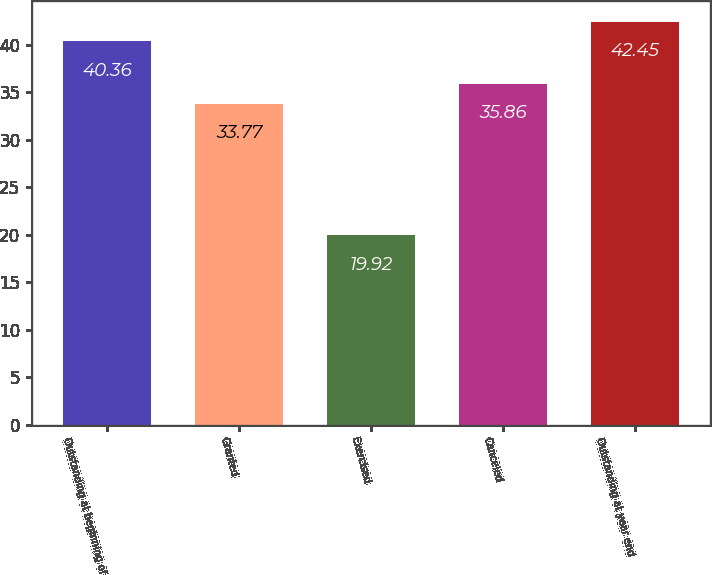<chart> <loc_0><loc_0><loc_500><loc_500><bar_chart><fcel>Outstanding at beginning of<fcel>Granted<fcel>Exercised<fcel>Canceled<fcel>Outstanding at year end<nl><fcel>40.36<fcel>33.77<fcel>19.92<fcel>35.86<fcel>42.45<nl></chart> 